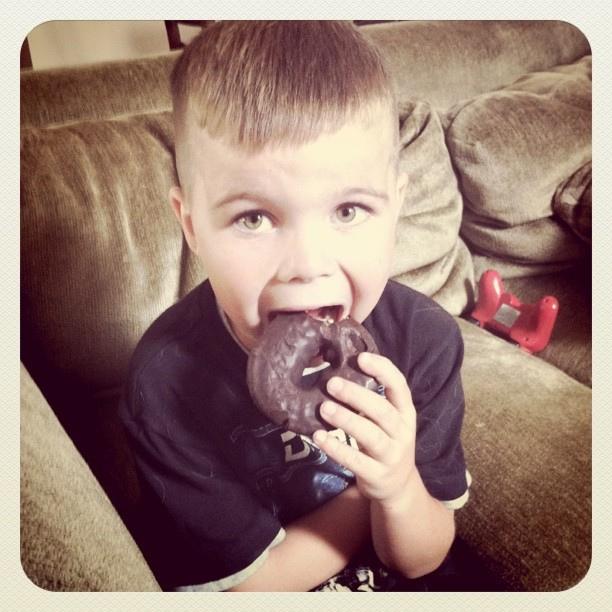What is the donut frosted with?
Quick response, please. Chocolate. Is this kid aware of the camera?
Quick response, please. Yes. Is the pad on the sofa of a PlayStation?
Give a very brief answer. Yes. 